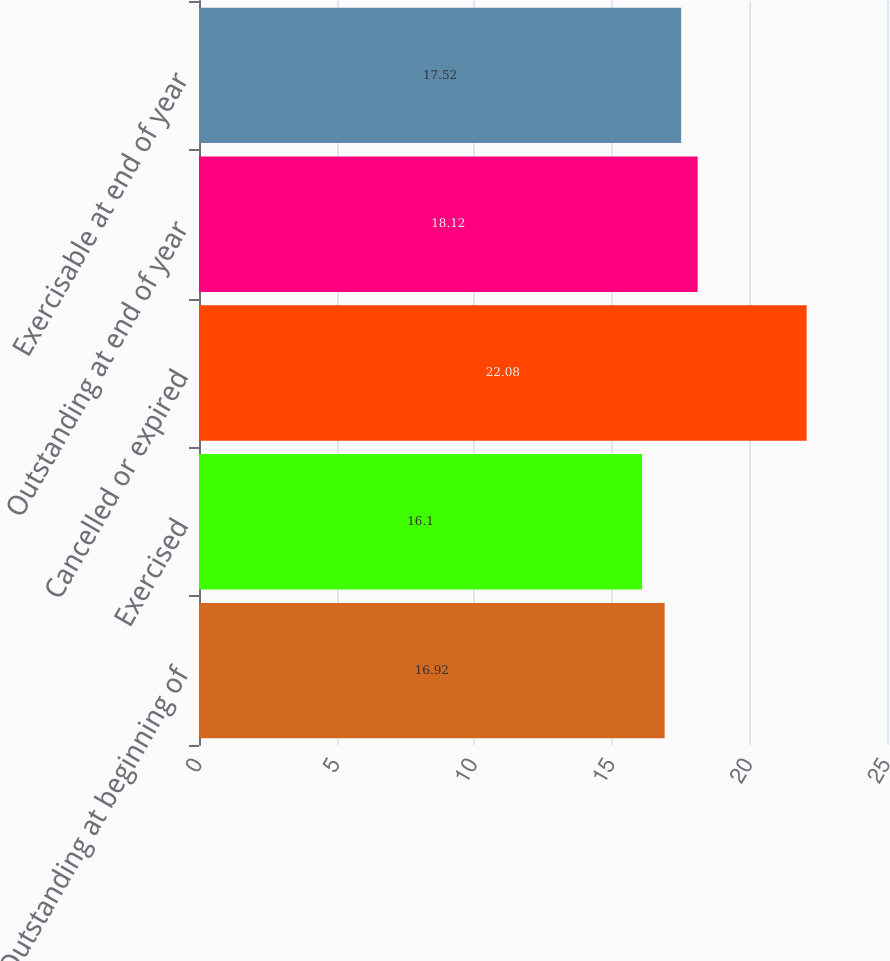<chart> <loc_0><loc_0><loc_500><loc_500><bar_chart><fcel>Outstanding at beginning of<fcel>Exercised<fcel>Cancelled or expired<fcel>Outstanding at end of year<fcel>Exercisable at end of year<nl><fcel>16.92<fcel>16.1<fcel>22.08<fcel>18.12<fcel>17.52<nl></chart> 